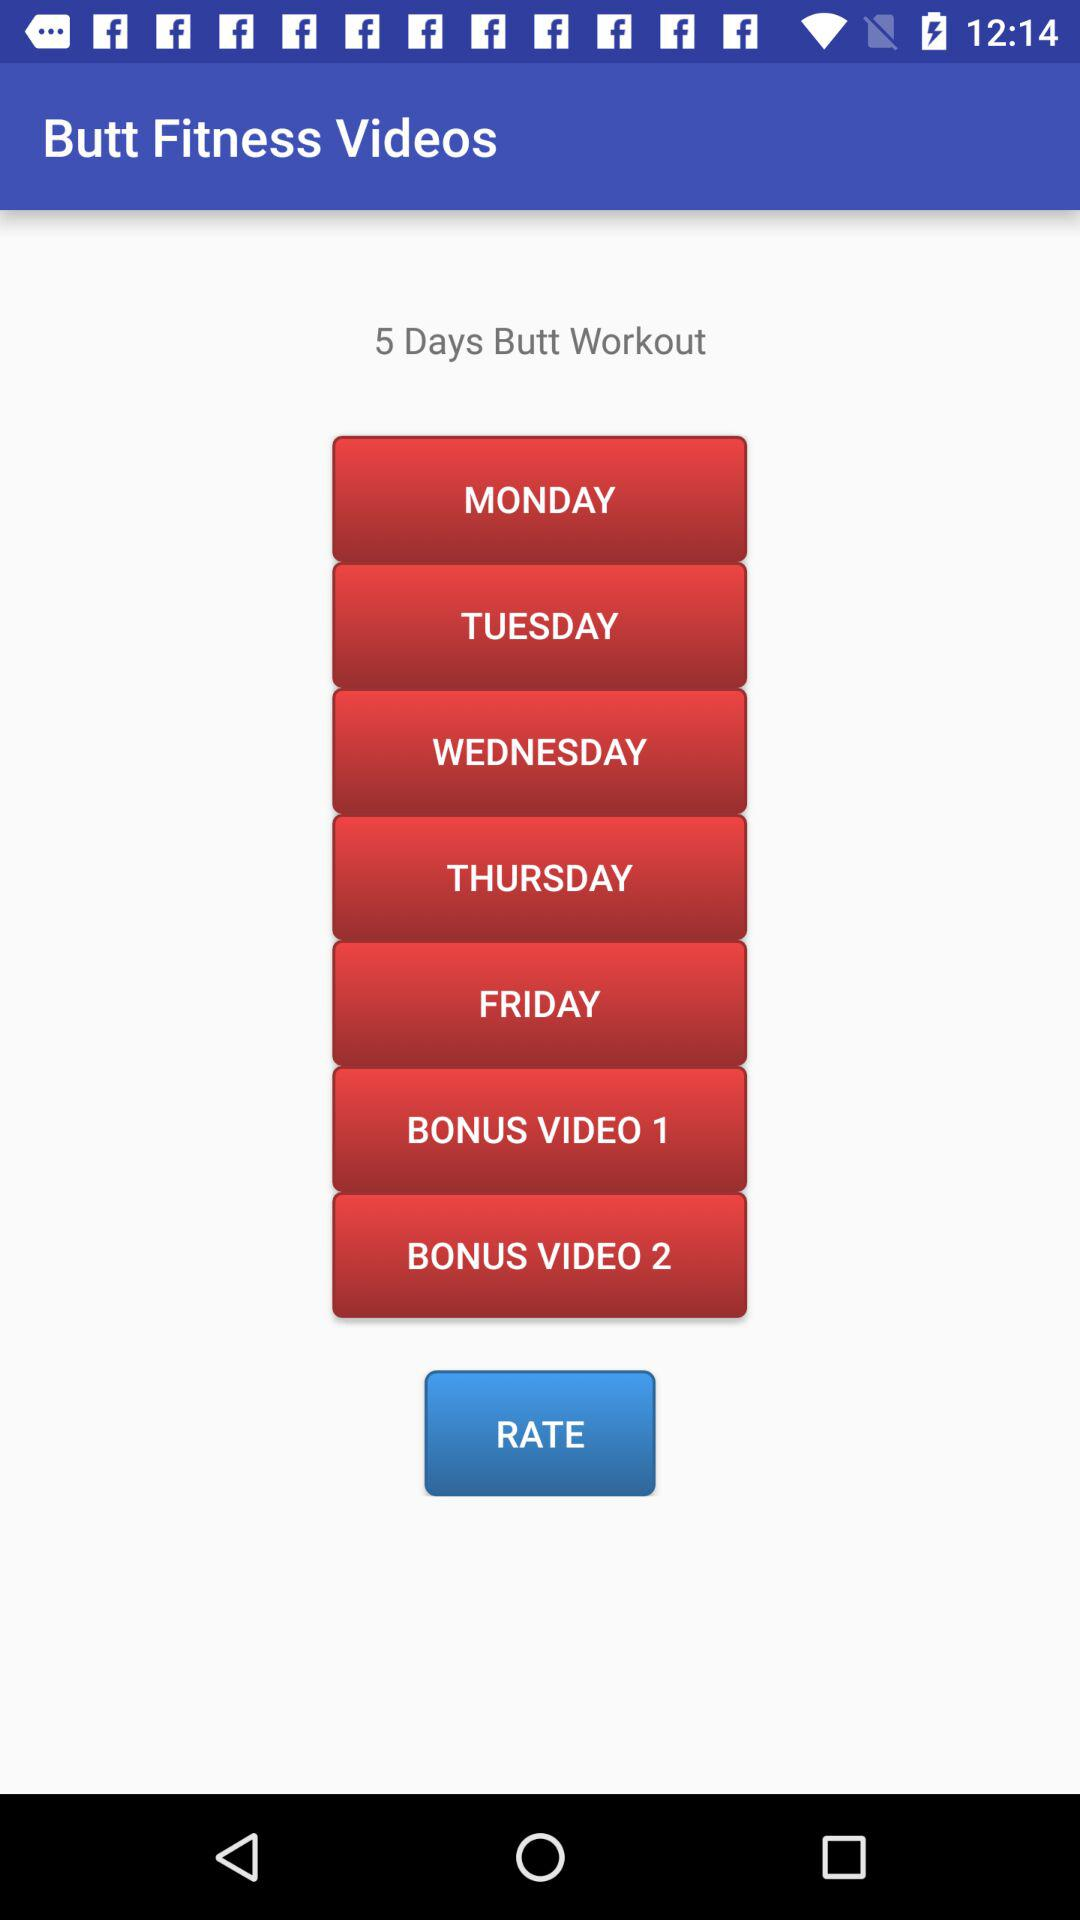What is the number of days of butt workout? The number of days is 5. 